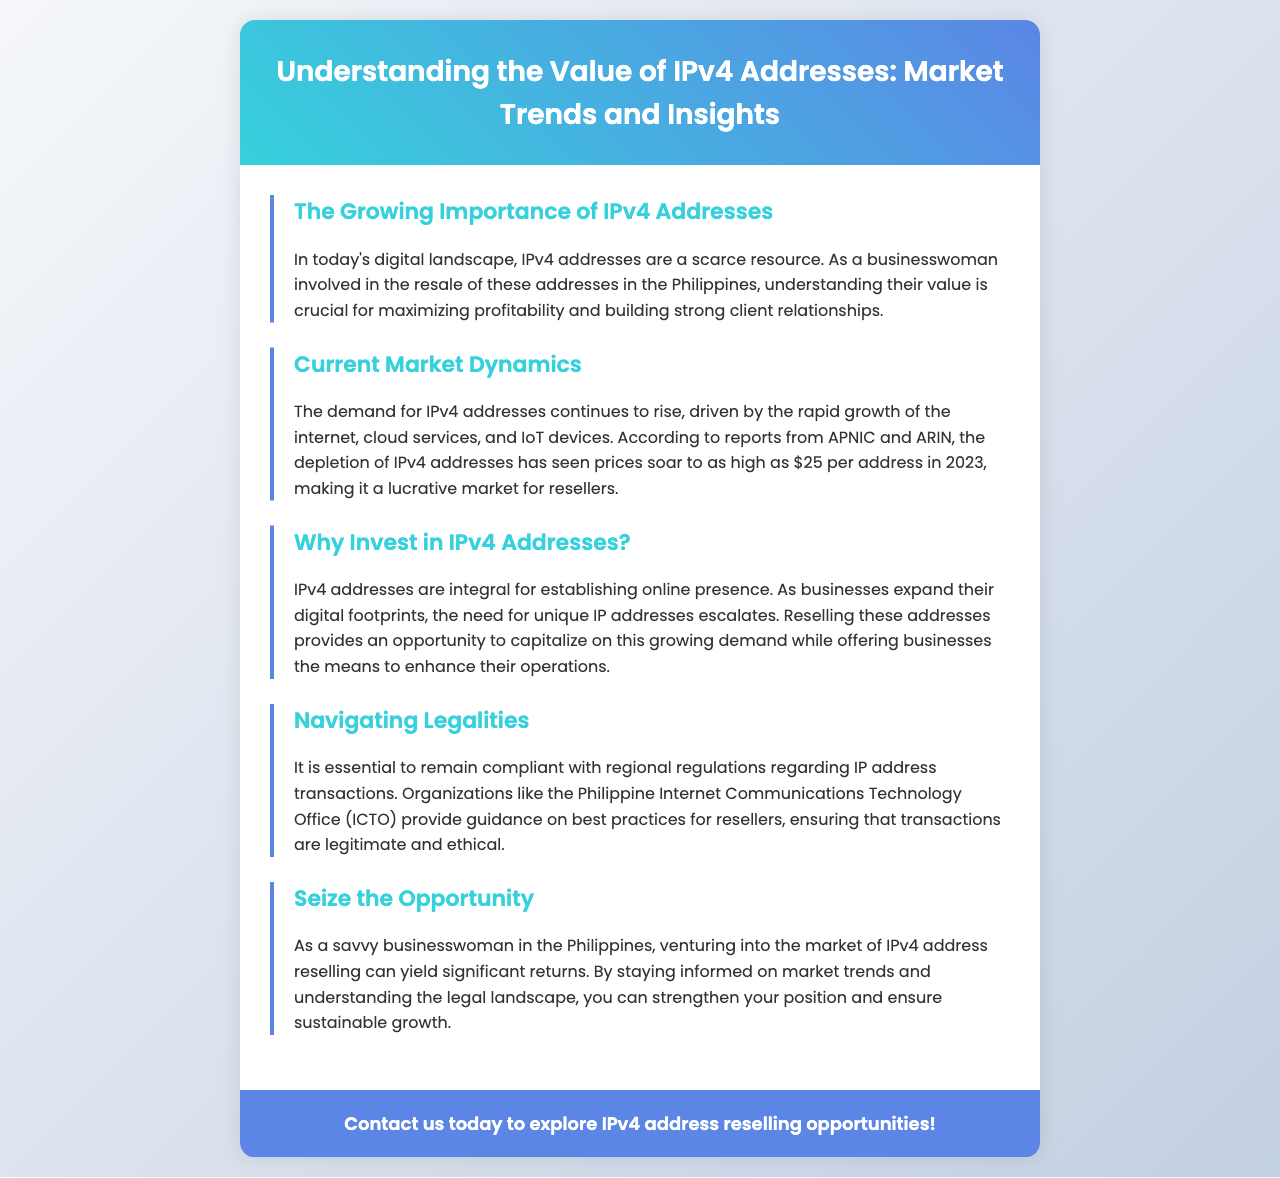What is the title of the brochure? The title of the brochure is presented in the header section, clearly indicating the main topic of the document.
Answer: Understanding the Value of IPv4 Addresses: Market Trends and Insights How much can IPv4 addresses sell for in 2023? The document mentions specific pricing trends in the current market section, highlighting the price as of 2023.
Answer: $25 What organization provides guidance for IP address transactions in the Philippines? The document refers to an organization that helps ensure compliance with regulations concerning IP address transactions.
Answer: Philippine Internet Communications Technology Office (ICTO) What is driving the demand for IPv4 addresses? The current market dynamics section explains the factors contributing to the increasing need for IPv4 addresses.
Answer: Growth of the internet, cloud services, and IoT devices What is the key opportunity highlighted for businesswomen in the brochure? The document emphasizes an opportunity for resellers in the IPv4 address market, specifically targeting businesswomen.
Answer: Significant returns through reselling Which segment discusses the legal aspects of reselling IP addresses? The legal considerations regarding transactions are addressed in one of the sections of the brochure.
Answer: Navigating Legalities What is one reason to invest in IPv4 addresses? The section on investment outlines a compelling reason to enter the IPv4 address market.
Answer: Establishing online presence 